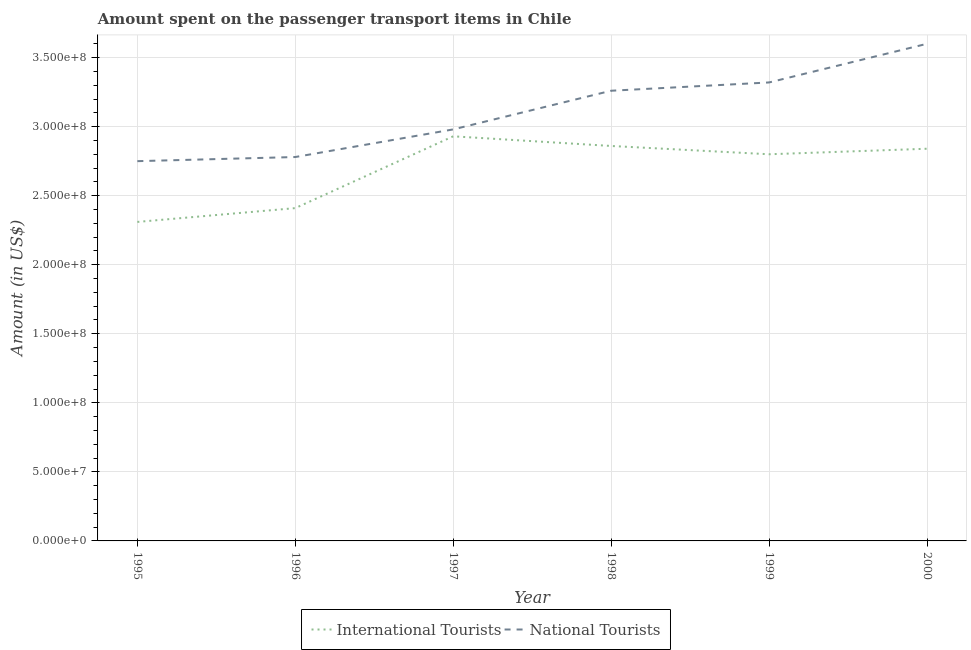Is the number of lines equal to the number of legend labels?
Ensure brevity in your answer.  Yes. What is the amount spent on transport items of international tourists in 2000?
Keep it short and to the point. 2.84e+08. Across all years, what is the maximum amount spent on transport items of international tourists?
Offer a very short reply. 2.93e+08. Across all years, what is the minimum amount spent on transport items of international tourists?
Offer a very short reply. 2.31e+08. In which year was the amount spent on transport items of international tourists maximum?
Your answer should be very brief. 1997. What is the total amount spent on transport items of international tourists in the graph?
Provide a succinct answer. 1.62e+09. What is the difference between the amount spent on transport items of international tourists in 1995 and that in 1998?
Offer a very short reply. -5.50e+07. What is the difference between the amount spent on transport items of international tourists in 1997 and the amount spent on transport items of national tourists in 1995?
Give a very brief answer. 1.80e+07. What is the average amount spent on transport items of international tourists per year?
Offer a terse response. 2.69e+08. In the year 1995, what is the difference between the amount spent on transport items of national tourists and amount spent on transport items of international tourists?
Offer a very short reply. 4.40e+07. What is the ratio of the amount spent on transport items of international tourists in 1995 to that in 2000?
Ensure brevity in your answer.  0.81. Is the amount spent on transport items of international tourists in 1997 less than that in 1999?
Make the answer very short. No. Is the difference between the amount spent on transport items of national tourists in 1999 and 2000 greater than the difference between the amount spent on transport items of international tourists in 1999 and 2000?
Ensure brevity in your answer.  No. What is the difference between the highest and the second highest amount spent on transport items of international tourists?
Offer a terse response. 7.00e+06. What is the difference between the highest and the lowest amount spent on transport items of international tourists?
Your answer should be compact. 6.20e+07. In how many years, is the amount spent on transport items of national tourists greater than the average amount spent on transport items of national tourists taken over all years?
Provide a short and direct response. 3. Does the amount spent on transport items of international tourists monotonically increase over the years?
Offer a terse response. No. Is the amount spent on transport items of national tourists strictly less than the amount spent on transport items of international tourists over the years?
Your answer should be very brief. No. How many lines are there?
Give a very brief answer. 2. How many years are there in the graph?
Give a very brief answer. 6. Are the values on the major ticks of Y-axis written in scientific E-notation?
Make the answer very short. Yes. Does the graph contain grids?
Provide a succinct answer. Yes. Where does the legend appear in the graph?
Provide a succinct answer. Bottom center. How many legend labels are there?
Provide a succinct answer. 2. What is the title of the graph?
Ensure brevity in your answer.  Amount spent on the passenger transport items in Chile. What is the label or title of the X-axis?
Give a very brief answer. Year. What is the Amount (in US$) of International Tourists in 1995?
Offer a very short reply. 2.31e+08. What is the Amount (in US$) of National Tourists in 1995?
Keep it short and to the point. 2.75e+08. What is the Amount (in US$) in International Tourists in 1996?
Your response must be concise. 2.41e+08. What is the Amount (in US$) in National Tourists in 1996?
Provide a succinct answer. 2.78e+08. What is the Amount (in US$) in International Tourists in 1997?
Your response must be concise. 2.93e+08. What is the Amount (in US$) of National Tourists in 1997?
Your answer should be compact. 2.98e+08. What is the Amount (in US$) of International Tourists in 1998?
Offer a very short reply. 2.86e+08. What is the Amount (in US$) in National Tourists in 1998?
Give a very brief answer. 3.26e+08. What is the Amount (in US$) in International Tourists in 1999?
Give a very brief answer. 2.80e+08. What is the Amount (in US$) in National Tourists in 1999?
Your answer should be very brief. 3.32e+08. What is the Amount (in US$) of International Tourists in 2000?
Keep it short and to the point. 2.84e+08. What is the Amount (in US$) in National Tourists in 2000?
Your response must be concise. 3.60e+08. Across all years, what is the maximum Amount (in US$) of International Tourists?
Make the answer very short. 2.93e+08. Across all years, what is the maximum Amount (in US$) of National Tourists?
Your answer should be compact. 3.60e+08. Across all years, what is the minimum Amount (in US$) in International Tourists?
Your answer should be very brief. 2.31e+08. Across all years, what is the minimum Amount (in US$) in National Tourists?
Your answer should be compact. 2.75e+08. What is the total Amount (in US$) in International Tourists in the graph?
Your answer should be compact. 1.62e+09. What is the total Amount (in US$) in National Tourists in the graph?
Ensure brevity in your answer.  1.87e+09. What is the difference between the Amount (in US$) of International Tourists in 1995 and that in 1996?
Keep it short and to the point. -1.00e+07. What is the difference between the Amount (in US$) of National Tourists in 1995 and that in 1996?
Keep it short and to the point. -3.00e+06. What is the difference between the Amount (in US$) in International Tourists in 1995 and that in 1997?
Your answer should be compact. -6.20e+07. What is the difference between the Amount (in US$) of National Tourists in 1995 and that in 1997?
Your answer should be very brief. -2.30e+07. What is the difference between the Amount (in US$) of International Tourists in 1995 and that in 1998?
Offer a terse response. -5.50e+07. What is the difference between the Amount (in US$) in National Tourists in 1995 and that in 1998?
Make the answer very short. -5.10e+07. What is the difference between the Amount (in US$) of International Tourists in 1995 and that in 1999?
Offer a terse response. -4.90e+07. What is the difference between the Amount (in US$) of National Tourists in 1995 and that in 1999?
Your response must be concise. -5.70e+07. What is the difference between the Amount (in US$) in International Tourists in 1995 and that in 2000?
Provide a short and direct response. -5.30e+07. What is the difference between the Amount (in US$) of National Tourists in 1995 and that in 2000?
Your answer should be very brief. -8.50e+07. What is the difference between the Amount (in US$) in International Tourists in 1996 and that in 1997?
Make the answer very short. -5.20e+07. What is the difference between the Amount (in US$) of National Tourists in 1996 and that in 1997?
Provide a short and direct response. -2.00e+07. What is the difference between the Amount (in US$) of International Tourists in 1996 and that in 1998?
Your answer should be compact. -4.50e+07. What is the difference between the Amount (in US$) of National Tourists in 1996 and that in 1998?
Your response must be concise. -4.80e+07. What is the difference between the Amount (in US$) of International Tourists in 1996 and that in 1999?
Keep it short and to the point. -3.90e+07. What is the difference between the Amount (in US$) of National Tourists in 1996 and that in 1999?
Your response must be concise. -5.40e+07. What is the difference between the Amount (in US$) in International Tourists in 1996 and that in 2000?
Offer a very short reply. -4.30e+07. What is the difference between the Amount (in US$) of National Tourists in 1996 and that in 2000?
Your answer should be very brief. -8.20e+07. What is the difference between the Amount (in US$) of International Tourists in 1997 and that in 1998?
Offer a terse response. 7.00e+06. What is the difference between the Amount (in US$) of National Tourists in 1997 and that in 1998?
Your answer should be compact. -2.80e+07. What is the difference between the Amount (in US$) in International Tourists in 1997 and that in 1999?
Provide a succinct answer. 1.30e+07. What is the difference between the Amount (in US$) of National Tourists in 1997 and that in 1999?
Provide a succinct answer. -3.40e+07. What is the difference between the Amount (in US$) in International Tourists in 1997 and that in 2000?
Offer a very short reply. 9.00e+06. What is the difference between the Amount (in US$) in National Tourists in 1997 and that in 2000?
Provide a succinct answer. -6.20e+07. What is the difference between the Amount (in US$) in National Tourists in 1998 and that in 1999?
Give a very brief answer. -6.00e+06. What is the difference between the Amount (in US$) of National Tourists in 1998 and that in 2000?
Offer a terse response. -3.40e+07. What is the difference between the Amount (in US$) in International Tourists in 1999 and that in 2000?
Make the answer very short. -4.00e+06. What is the difference between the Amount (in US$) in National Tourists in 1999 and that in 2000?
Ensure brevity in your answer.  -2.80e+07. What is the difference between the Amount (in US$) in International Tourists in 1995 and the Amount (in US$) in National Tourists in 1996?
Make the answer very short. -4.70e+07. What is the difference between the Amount (in US$) in International Tourists in 1995 and the Amount (in US$) in National Tourists in 1997?
Provide a succinct answer. -6.70e+07. What is the difference between the Amount (in US$) of International Tourists in 1995 and the Amount (in US$) of National Tourists in 1998?
Your answer should be very brief. -9.50e+07. What is the difference between the Amount (in US$) of International Tourists in 1995 and the Amount (in US$) of National Tourists in 1999?
Provide a short and direct response. -1.01e+08. What is the difference between the Amount (in US$) in International Tourists in 1995 and the Amount (in US$) in National Tourists in 2000?
Offer a terse response. -1.29e+08. What is the difference between the Amount (in US$) of International Tourists in 1996 and the Amount (in US$) of National Tourists in 1997?
Keep it short and to the point. -5.70e+07. What is the difference between the Amount (in US$) of International Tourists in 1996 and the Amount (in US$) of National Tourists in 1998?
Ensure brevity in your answer.  -8.50e+07. What is the difference between the Amount (in US$) in International Tourists in 1996 and the Amount (in US$) in National Tourists in 1999?
Your answer should be compact. -9.10e+07. What is the difference between the Amount (in US$) of International Tourists in 1996 and the Amount (in US$) of National Tourists in 2000?
Ensure brevity in your answer.  -1.19e+08. What is the difference between the Amount (in US$) of International Tourists in 1997 and the Amount (in US$) of National Tourists in 1998?
Ensure brevity in your answer.  -3.30e+07. What is the difference between the Amount (in US$) of International Tourists in 1997 and the Amount (in US$) of National Tourists in 1999?
Your answer should be compact. -3.90e+07. What is the difference between the Amount (in US$) in International Tourists in 1997 and the Amount (in US$) in National Tourists in 2000?
Provide a succinct answer. -6.70e+07. What is the difference between the Amount (in US$) in International Tourists in 1998 and the Amount (in US$) in National Tourists in 1999?
Give a very brief answer. -4.60e+07. What is the difference between the Amount (in US$) of International Tourists in 1998 and the Amount (in US$) of National Tourists in 2000?
Make the answer very short. -7.40e+07. What is the difference between the Amount (in US$) of International Tourists in 1999 and the Amount (in US$) of National Tourists in 2000?
Your response must be concise. -8.00e+07. What is the average Amount (in US$) of International Tourists per year?
Your answer should be compact. 2.69e+08. What is the average Amount (in US$) of National Tourists per year?
Offer a terse response. 3.12e+08. In the year 1995, what is the difference between the Amount (in US$) in International Tourists and Amount (in US$) in National Tourists?
Offer a terse response. -4.40e+07. In the year 1996, what is the difference between the Amount (in US$) of International Tourists and Amount (in US$) of National Tourists?
Ensure brevity in your answer.  -3.70e+07. In the year 1997, what is the difference between the Amount (in US$) in International Tourists and Amount (in US$) in National Tourists?
Your answer should be compact. -5.00e+06. In the year 1998, what is the difference between the Amount (in US$) of International Tourists and Amount (in US$) of National Tourists?
Offer a very short reply. -4.00e+07. In the year 1999, what is the difference between the Amount (in US$) in International Tourists and Amount (in US$) in National Tourists?
Make the answer very short. -5.20e+07. In the year 2000, what is the difference between the Amount (in US$) of International Tourists and Amount (in US$) of National Tourists?
Provide a succinct answer. -7.60e+07. What is the ratio of the Amount (in US$) in International Tourists in 1995 to that in 1996?
Your answer should be very brief. 0.96. What is the ratio of the Amount (in US$) in International Tourists in 1995 to that in 1997?
Offer a terse response. 0.79. What is the ratio of the Amount (in US$) of National Tourists in 1995 to that in 1997?
Offer a very short reply. 0.92. What is the ratio of the Amount (in US$) in International Tourists in 1995 to that in 1998?
Your answer should be very brief. 0.81. What is the ratio of the Amount (in US$) of National Tourists in 1995 to that in 1998?
Keep it short and to the point. 0.84. What is the ratio of the Amount (in US$) in International Tourists in 1995 to that in 1999?
Make the answer very short. 0.82. What is the ratio of the Amount (in US$) in National Tourists in 1995 to that in 1999?
Make the answer very short. 0.83. What is the ratio of the Amount (in US$) of International Tourists in 1995 to that in 2000?
Your response must be concise. 0.81. What is the ratio of the Amount (in US$) of National Tourists in 1995 to that in 2000?
Give a very brief answer. 0.76. What is the ratio of the Amount (in US$) of International Tourists in 1996 to that in 1997?
Ensure brevity in your answer.  0.82. What is the ratio of the Amount (in US$) of National Tourists in 1996 to that in 1997?
Offer a terse response. 0.93. What is the ratio of the Amount (in US$) of International Tourists in 1996 to that in 1998?
Keep it short and to the point. 0.84. What is the ratio of the Amount (in US$) in National Tourists in 1996 to that in 1998?
Provide a short and direct response. 0.85. What is the ratio of the Amount (in US$) in International Tourists in 1996 to that in 1999?
Provide a short and direct response. 0.86. What is the ratio of the Amount (in US$) in National Tourists in 1996 to that in 1999?
Ensure brevity in your answer.  0.84. What is the ratio of the Amount (in US$) in International Tourists in 1996 to that in 2000?
Your response must be concise. 0.85. What is the ratio of the Amount (in US$) of National Tourists in 1996 to that in 2000?
Provide a short and direct response. 0.77. What is the ratio of the Amount (in US$) in International Tourists in 1997 to that in 1998?
Make the answer very short. 1.02. What is the ratio of the Amount (in US$) in National Tourists in 1997 to that in 1998?
Provide a succinct answer. 0.91. What is the ratio of the Amount (in US$) of International Tourists in 1997 to that in 1999?
Provide a succinct answer. 1.05. What is the ratio of the Amount (in US$) in National Tourists in 1997 to that in 1999?
Offer a very short reply. 0.9. What is the ratio of the Amount (in US$) of International Tourists in 1997 to that in 2000?
Make the answer very short. 1.03. What is the ratio of the Amount (in US$) of National Tourists in 1997 to that in 2000?
Your answer should be very brief. 0.83. What is the ratio of the Amount (in US$) in International Tourists in 1998 to that in 1999?
Your answer should be compact. 1.02. What is the ratio of the Amount (in US$) of National Tourists in 1998 to that in 1999?
Your answer should be very brief. 0.98. What is the ratio of the Amount (in US$) in International Tourists in 1998 to that in 2000?
Offer a very short reply. 1.01. What is the ratio of the Amount (in US$) in National Tourists in 1998 to that in 2000?
Keep it short and to the point. 0.91. What is the ratio of the Amount (in US$) of International Tourists in 1999 to that in 2000?
Provide a succinct answer. 0.99. What is the ratio of the Amount (in US$) in National Tourists in 1999 to that in 2000?
Your answer should be compact. 0.92. What is the difference between the highest and the second highest Amount (in US$) of International Tourists?
Offer a very short reply. 7.00e+06. What is the difference between the highest and the second highest Amount (in US$) of National Tourists?
Your response must be concise. 2.80e+07. What is the difference between the highest and the lowest Amount (in US$) of International Tourists?
Offer a very short reply. 6.20e+07. What is the difference between the highest and the lowest Amount (in US$) of National Tourists?
Provide a succinct answer. 8.50e+07. 